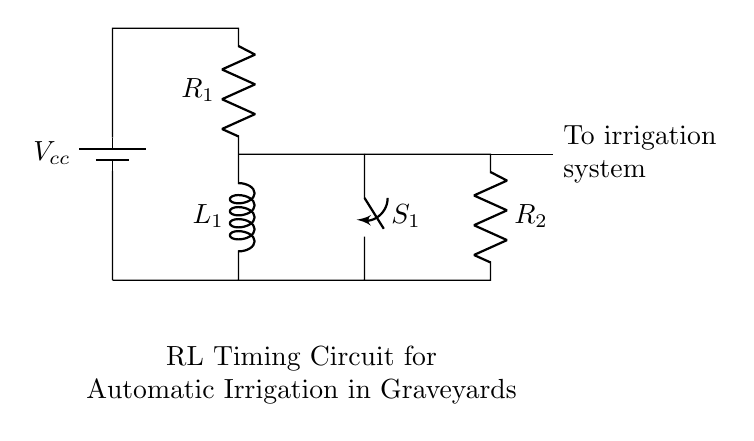What are the main components in this circuit? The circuit contains a battery, a resistor (R1), an inductor (L1), another resistor (R2), and a switch (S1). These can be identified by their symbols in the diagram.
Answer: battery, R1, L1, R2, S1 What is the function of the switch S1? The switch S1 controls the flow of current through the circuit. When closed, it allows current to flow, affecting the timing of the irrigation system.
Answer: Control current flow What does the RL circuit primarily control? The RL circuit primarily controls the timing of the automatic irrigation system, allowing water to flow for a set period based on the inductor's properties.
Answer: Timing of irrigation What is the role of the inductor L1 in this circuit? The inductor L1 stores energy in its magnetic field when current flows through it, affecting the timing and delay of the current passing to the irrigation system.
Answer: Energy storage How many resistors are present in the circuit? There are two resistors (R1 and R2) in the circuit, as indicated by the symbols and their labels.
Answer: Two What will happen if the switch S1 is left open? If the switch S1 is left open, no current will flow through the circuit, and the irrigation system will not operate, resulting in no water being distributed to the graves.
Answer: No current flow 